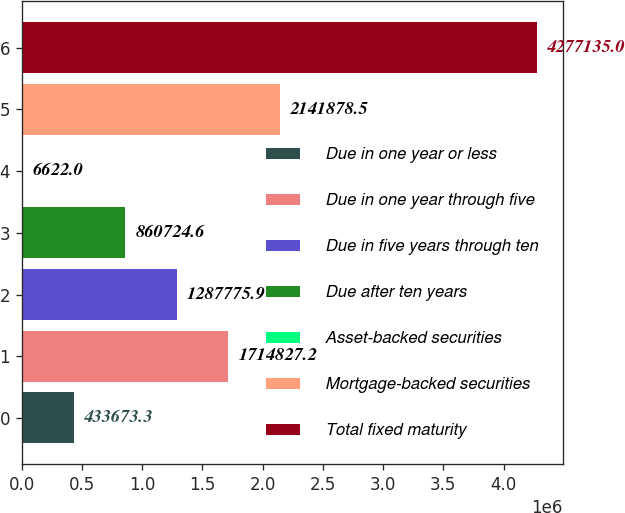Convert chart. <chart><loc_0><loc_0><loc_500><loc_500><bar_chart><fcel>Due in one year or less<fcel>Due in one year through five<fcel>Due in five years through ten<fcel>Due after ten years<fcel>Asset-backed securities<fcel>Mortgage-backed securities<fcel>Total fixed maturity<nl><fcel>433673<fcel>1.71483e+06<fcel>1.28778e+06<fcel>860725<fcel>6622<fcel>2.14188e+06<fcel>4.27714e+06<nl></chart> 